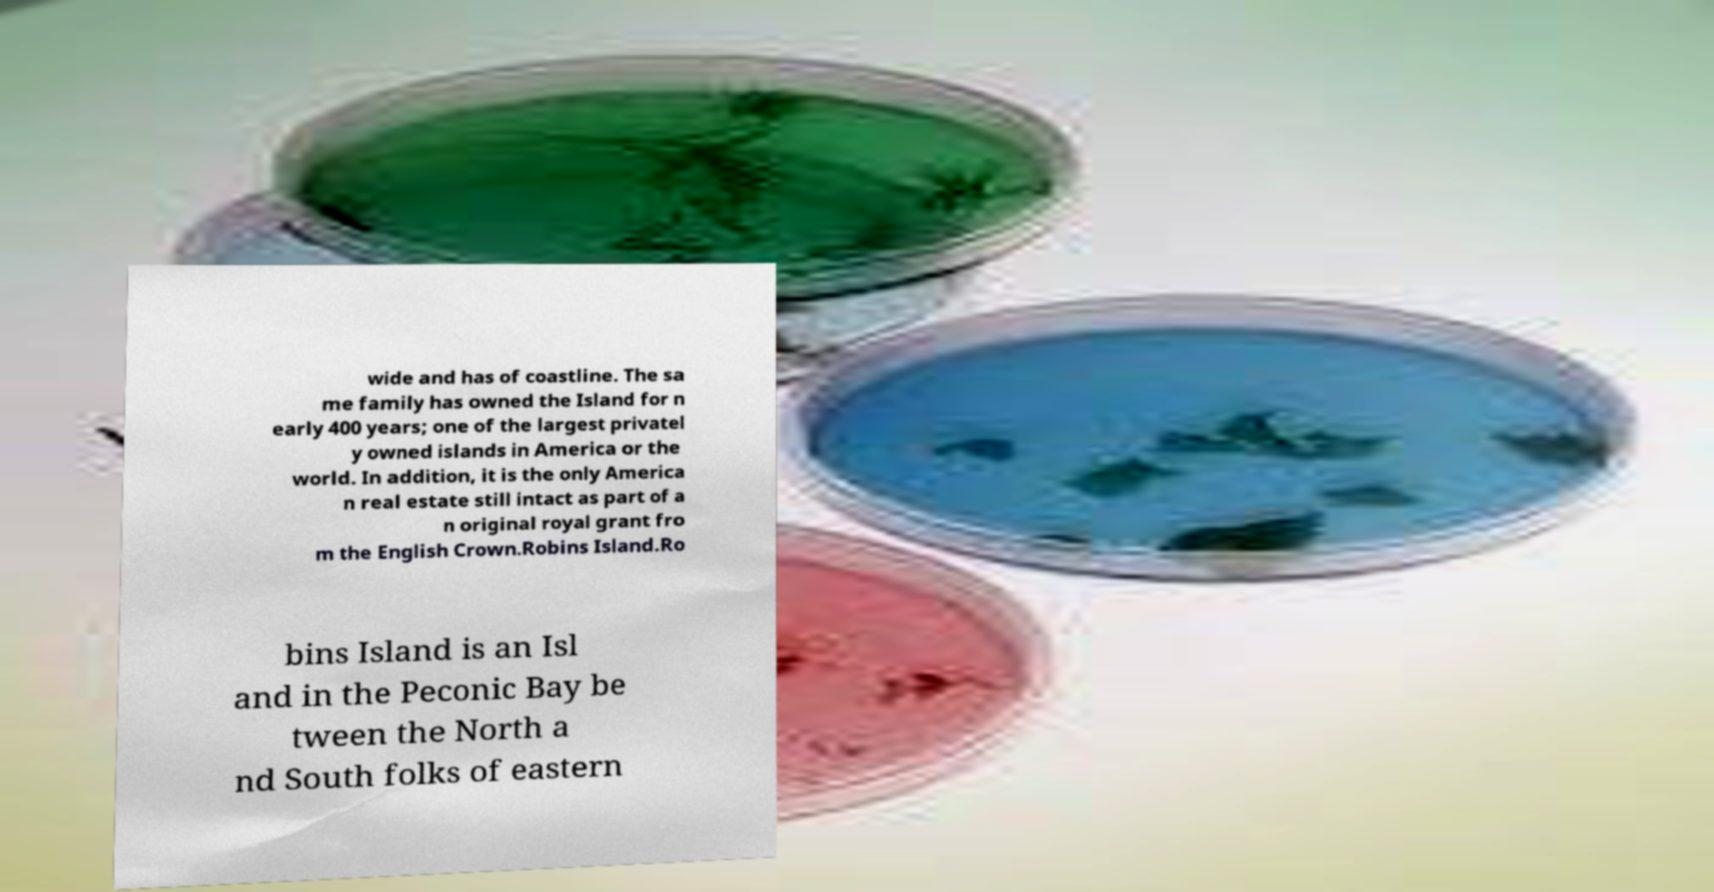Can you accurately transcribe the text from the provided image for me? wide and has of coastline. The sa me family has owned the Island for n early 400 years; one of the largest privatel y owned islands in America or the world. In addition, it is the only America n real estate still intact as part of a n original royal grant fro m the English Crown.Robins Island.Ro bins Island is an Isl and in the Peconic Bay be tween the North a nd South folks of eastern 